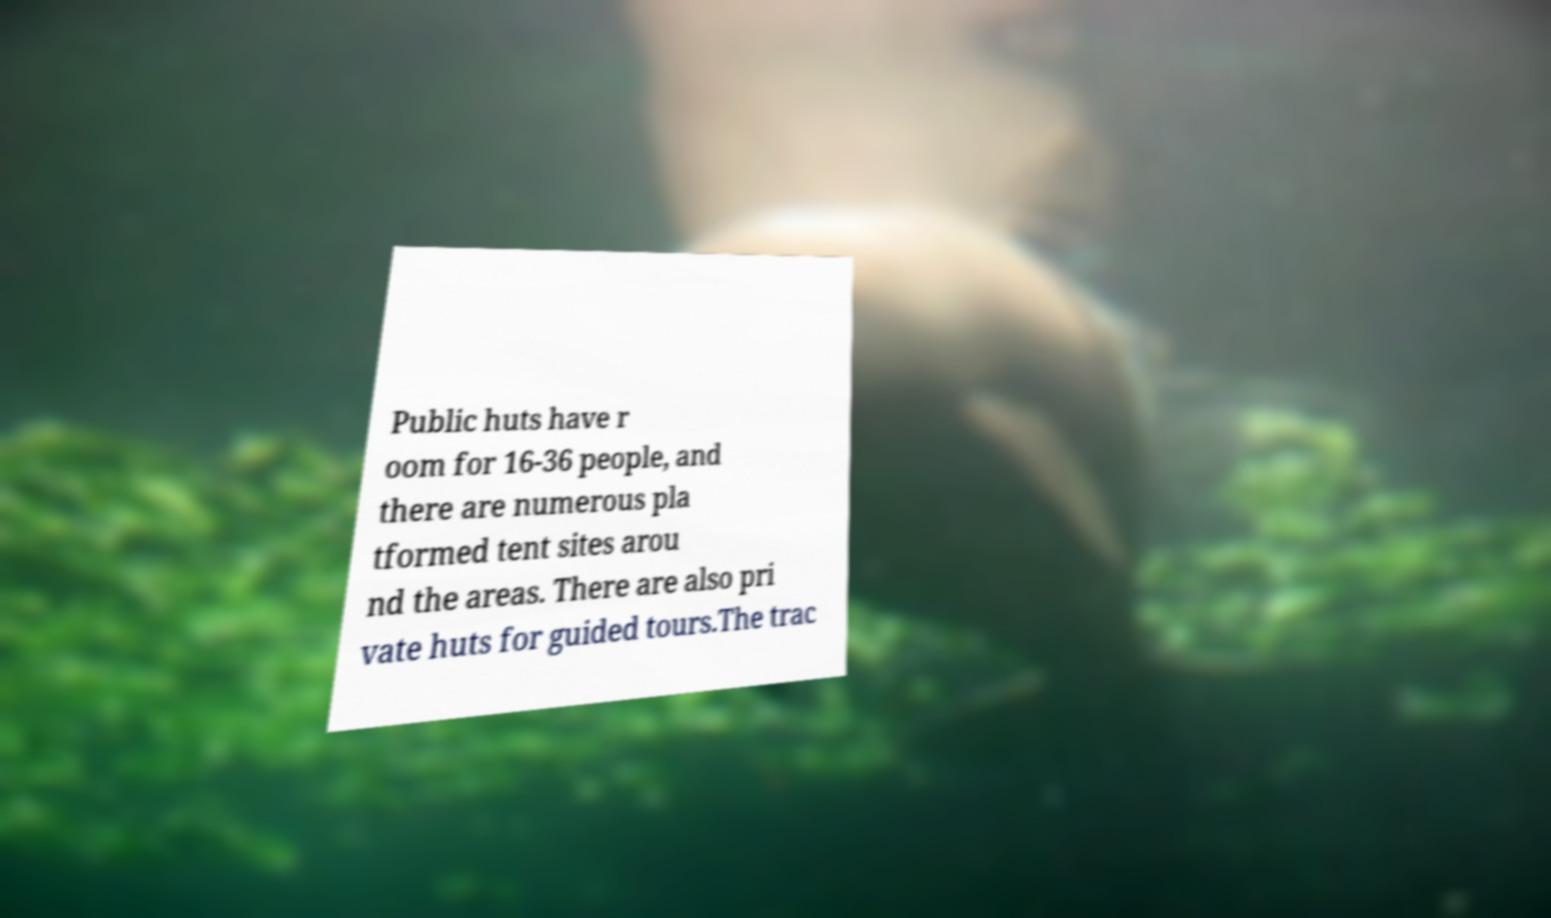Can you accurately transcribe the text from the provided image for me? Public huts have r oom for 16-36 people, and there are numerous pla tformed tent sites arou nd the areas. There are also pri vate huts for guided tours.The trac 